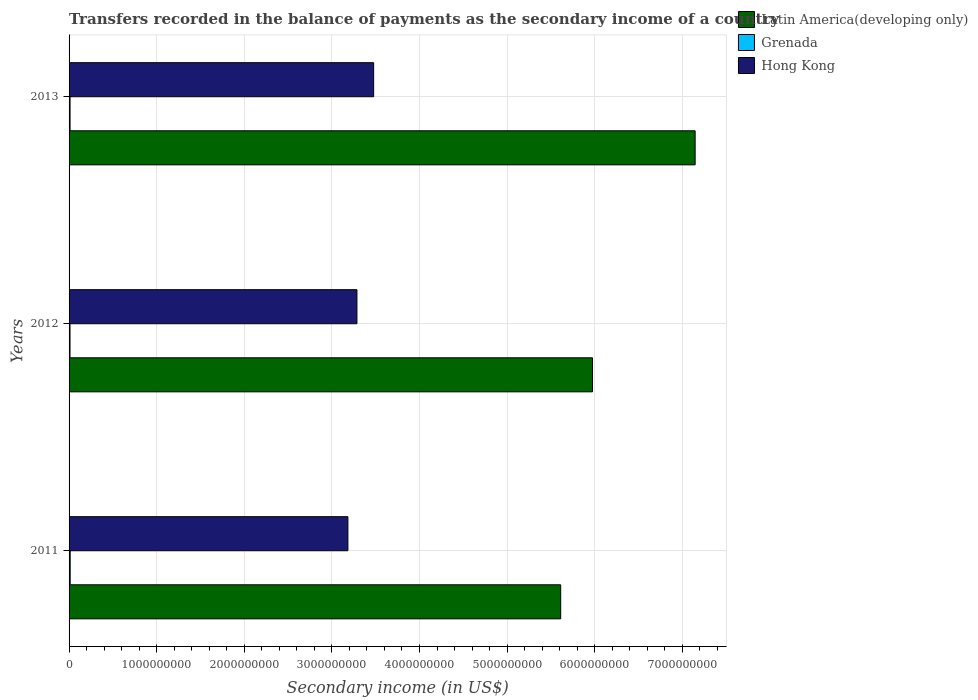How many different coloured bars are there?
Make the answer very short. 3. How many bars are there on the 2nd tick from the top?
Provide a short and direct response. 3. What is the secondary income of in Hong Kong in 2012?
Keep it short and to the point. 3.29e+09. Across all years, what is the maximum secondary income of in Hong Kong?
Ensure brevity in your answer.  3.48e+09. Across all years, what is the minimum secondary income of in Latin America(developing only)?
Give a very brief answer. 5.61e+09. In which year was the secondary income of in Latin America(developing only) minimum?
Provide a short and direct response. 2011. What is the total secondary income of in Hong Kong in the graph?
Keep it short and to the point. 9.95e+09. What is the difference between the secondary income of in Hong Kong in 2011 and that in 2012?
Provide a succinct answer. -1.03e+08. What is the difference between the secondary income of in Latin America(developing only) in 2013 and the secondary income of in Grenada in 2012?
Provide a short and direct response. 7.14e+09. What is the average secondary income of in Grenada per year?
Ensure brevity in your answer.  1.16e+07. In the year 2012, what is the difference between the secondary income of in Hong Kong and secondary income of in Latin America(developing only)?
Provide a succinct answer. -2.69e+09. What is the ratio of the secondary income of in Latin America(developing only) in 2012 to that in 2013?
Make the answer very short. 0.84. Is the secondary income of in Latin America(developing only) in 2011 less than that in 2013?
Your answer should be very brief. Yes. What is the difference between the highest and the second highest secondary income of in Grenada?
Your answer should be compact. 1.58e+06. What is the difference between the highest and the lowest secondary income of in Grenada?
Your response must be concise. 2.02e+06. In how many years, is the secondary income of in Latin America(developing only) greater than the average secondary income of in Latin America(developing only) taken over all years?
Offer a terse response. 1. What does the 1st bar from the top in 2013 represents?
Offer a very short reply. Hong Kong. What does the 1st bar from the bottom in 2013 represents?
Provide a succinct answer. Latin America(developing only). Is it the case that in every year, the sum of the secondary income of in Hong Kong and secondary income of in Grenada is greater than the secondary income of in Latin America(developing only)?
Offer a very short reply. No. How many bars are there?
Make the answer very short. 9. Are all the bars in the graph horizontal?
Provide a succinct answer. Yes. Does the graph contain any zero values?
Make the answer very short. No. What is the title of the graph?
Make the answer very short. Transfers recorded in the balance of payments as the secondary income of a country. Does "Low & middle income" appear as one of the legend labels in the graph?
Your answer should be compact. No. What is the label or title of the X-axis?
Your answer should be very brief. Secondary income (in US$). What is the Secondary income (in US$) of Latin America(developing only) in 2011?
Keep it short and to the point. 5.61e+09. What is the Secondary income (in US$) of Grenada in 2011?
Provide a short and direct response. 1.28e+07. What is the Secondary income (in US$) in Hong Kong in 2011?
Offer a very short reply. 3.18e+09. What is the Secondary income (in US$) in Latin America(developing only) in 2012?
Provide a succinct answer. 5.97e+09. What is the Secondary income (in US$) in Grenada in 2012?
Offer a very short reply. 1.08e+07. What is the Secondary income (in US$) in Hong Kong in 2012?
Your response must be concise. 3.29e+09. What is the Secondary income (in US$) of Latin America(developing only) in 2013?
Keep it short and to the point. 7.15e+09. What is the Secondary income (in US$) in Grenada in 2013?
Offer a terse response. 1.12e+07. What is the Secondary income (in US$) in Hong Kong in 2013?
Your answer should be compact. 3.48e+09. Across all years, what is the maximum Secondary income (in US$) of Latin America(developing only)?
Provide a short and direct response. 7.15e+09. Across all years, what is the maximum Secondary income (in US$) of Grenada?
Offer a very short reply. 1.28e+07. Across all years, what is the maximum Secondary income (in US$) of Hong Kong?
Your answer should be compact. 3.48e+09. Across all years, what is the minimum Secondary income (in US$) of Latin America(developing only)?
Ensure brevity in your answer.  5.61e+09. Across all years, what is the minimum Secondary income (in US$) in Grenada?
Your answer should be very brief. 1.08e+07. Across all years, what is the minimum Secondary income (in US$) in Hong Kong?
Provide a short and direct response. 3.18e+09. What is the total Secondary income (in US$) of Latin America(developing only) in the graph?
Your answer should be very brief. 1.87e+1. What is the total Secondary income (in US$) of Grenada in the graph?
Offer a terse response. 3.48e+07. What is the total Secondary income (in US$) in Hong Kong in the graph?
Provide a succinct answer. 9.95e+09. What is the difference between the Secondary income (in US$) in Latin America(developing only) in 2011 and that in 2012?
Offer a very short reply. -3.63e+08. What is the difference between the Secondary income (in US$) in Grenada in 2011 and that in 2012?
Your response must be concise. 2.02e+06. What is the difference between the Secondary income (in US$) of Hong Kong in 2011 and that in 2012?
Your answer should be very brief. -1.03e+08. What is the difference between the Secondary income (in US$) in Latin America(developing only) in 2011 and that in 2013?
Your answer should be compact. -1.53e+09. What is the difference between the Secondary income (in US$) of Grenada in 2011 and that in 2013?
Provide a short and direct response. 1.58e+06. What is the difference between the Secondary income (in US$) of Hong Kong in 2011 and that in 2013?
Offer a terse response. -2.94e+08. What is the difference between the Secondary income (in US$) of Latin America(developing only) in 2012 and that in 2013?
Your answer should be very brief. -1.17e+09. What is the difference between the Secondary income (in US$) in Grenada in 2012 and that in 2013?
Keep it short and to the point. -4.39e+05. What is the difference between the Secondary income (in US$) of Hong Kong in 2012 and that in 2013?
Offer a terse response. -1.91e+08. What is the difference between the Secondary income (in US$) in Latin America(developing only) in 2011 and the Secondary income (in US$) in Grenada in 2012?
Keep it short and to the point. 5.60e+09. What is the difference between the Secondary income (in US$) in Latin America(developing only) in 2011 and the Secondary income (in US$) in Hong Kong in 2012?
Offer a terse response. 2.33e+09. What is the difference between the Secondary income (in US$) in Grenada in 2011 and the Secondary income (in US$) in Hong Kong in 2012?
Give a very brief answer. -3.27e+09. What is the difference between the Secondary income (in US$) in Latin America(developing only) in 2011 and the Secondary income (in US$) in Grenada in 2013?
Keep it short and to the point. 5.60e+09. What is the difference between the Secondary income (in US$) of Latin America(developing only) in 2011 and the Secondary income (in US$) of Hong Kong in 2013?
Your answer should be compact. 2.13e+09. What is the difference between the Secondary income (in US$) of Grenada in 2011 and the Secondary income (in US$) of Hong Kong in 2013?
Ensure brevity in your answer.  -3.46e+09. What is the difference between the Secondary income (in US$) of Latin America(developing only) in 2012 and the Secondary income (in US$) of Grenada in 2013?
Keep it short and to the point. 5.96e+09. What is the difference between the Secondary income (in US$) in Latin America(developing only) in 2012 and the Secondary income (in US$) in Hong Kong in 2013?
Your answer should be compact. 2.50e+09. What is the difference between the Secondary income (in US$) of Grenada in 2012 and the Secondary income (in US$) of Hong Kong in 2013?
Provide a short and direct response. -3.47e+09. What is the average Secondary income (in US$) in Latin America(developing only) per year?
Provide a short and direct response. 6.24e+09. What is the average Secondary income (in US$) of Grenada per year?
Provide a short and direct response. 1.16e+07. What is the average Secondary income (in US$) in Hong Kong per year?
Your response must be concise. 3.32e+09. In the year 2011, what is the difference between the Secondary income (in US$) in Latin America(developing only) and Secondary income (in US$) in Grenada?
Offer a very short reply. 5.60e+09. In the year 2011, what is the difference between the Secondary income (in US$) of Latin America(developing only) and Secondary income (in US$) of Hong Kong?
Ensure brevity in your answer.  2.43e+09. In the year 2011, what is the difference between the Secondary income (in US$) of Grenada and Secondary income (in US$) of Hong Kong?
Provide a succinct answer. -3.17e+09. In the year 2012, what is the difference between the Secondary income (in US$) in Latin America(developing only) and Secondary income (in US$) in Grenada?
Give a very brief answer. 5.96e+09. In the year 2012, what is the difference between the Secondary income (in US$) of Latin America(developing only) and Secondary income (in US$) of Hong Kong?
Your response must be concise. 2.69e+09. In the year 2012, what is the difference between the Secondary income (in US$) in Grenada and Secondary income (in US$) in Hong Kong?
Keep it short and to the point. -3.28e+09. In the year 2013, what is the difference between the Secondary income (in US$) in Latin America(developing only) and Secondary income (in US$) in Grenada?
Your answer should be very brief. 7.14e+09. In the year 2013, what is the difference between the Secondary income (in US$) in Latin America(developing only) and Secondary income (in US$) in Hong Kong?
Make the answer very short. 3.67e+09. In the year 2013, what is the difference between the Secondary income (in US$) of Grenada and Secondary income (in US$) of Hong Kong?
Give a very brief answer. -3.47e+09. What is the ratio of the Secondary income (in US$) of Latin America(developing only) in 2011 to that in 2012?
Your response must be concise. 0.94. What is the ratio of the Secondary income (in US$) of Grenada in 2011 to that in 2012?
Provide a short and direct response. 1.19. What is the ratio of the Secondary income (in US$) of Hong Kong in 2011 to that in 2012?
Your answer should be compact. 0.97. What is the ratio of the Secondary income (in US$) of Latin America(developing only) in 2011 to that in 2013?
Ensure brevity in your answer.  0.79. What is the ratio of the Secondary income (in US$) in Grenada in 2011 to that in 2013?
Your answer should be very brief. 1.14. What is the ratio of the Secondary income (in US$) of Hong Kong in 2011 to that in 2013?
Make the answer very short. 0.92. What is the ratio of the Secondary income (in US$) of Latin America(developing only) in 2012 to that in 2013?
Keep it short and to the point. 0.84. What is the ratio of the Secondary income (in US$) of Grenada in 2012 to that in 2013?
Provide a short and direct response. 0.96. What is the ratio of the Secondary income (in US$) in Hong Kong in 2012 to that in 2013?
Make the answer very short. 0.95. What is the difference between the highest and the second highest Secondary income (in US$) in Latin America(developing only)?
Offer a terse response. 1.17e+09. What is the difference between the highest and the second highest Secondary income (in US$) of Grenada?
Keep it short and to the point. 1.58e+06. What is the difference between the highest and the second highest Secondary income (in US$) of Hong Kong?
Keep it short and to the point. 1.91e+08. What is the difference between the highest and the lowest Secondary income (in US$) in Latin America(developing only)?
Your response must be concise. 1.53e+09. What is the difference between the highest and the lowest Secondary income (in US$) in Grenada?
Offer a very short reply. 2.02e+06. What is the difference between the highest and the lowest Secondary income (in US$) in Hong Kong?
Make the answer very short. 2.94e+08. 